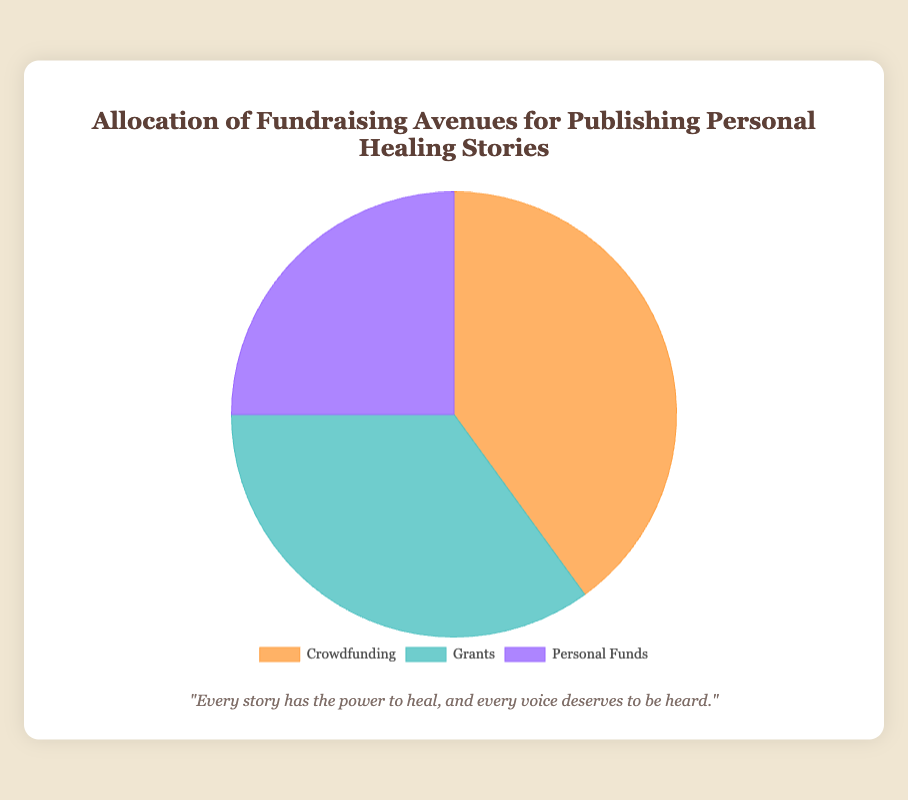What percentage of funds come from crowdfunding sources combined? According to the chart, crowdfunding accounts for 40% of the total fundraising avenues.
Answer: 40% Which fundraising avenue has the smallest percentage allocation? By looking at the pie chart, it's clear that Personal Funds have the smallest percentage at 25%.
Answer: Personal Funds Which avenue contributes more, Crowdfunding or Grants, and by how much? Crowdfunding accounts for 40% and Grants account for 35%. The difference between these two is 40% - 35%.
Answer: Crowdfunding by 5% What is the average percentage allocation across all three fundraising methods? To find the average, sum the percentages of all three methods: 40% (Crowdfunding) + 35% (Grants) + 25% (Personal Funds) = 100%, then divide by 3.
Answer: 33.33% Which section of the pie chart is represented by a bluish color? The bluish color in the pie chart represents Grants.
Answer: Grants How much more percentage comes from crowdfunding compared to personal funds? Crowdfunding is 40% and Personal Funds are 25%. The difference is 40% - 25%.
Answer: 15% What is the total percentage shared by Crowdfunding and Personal Funds? Sum the percentages of Crowdfunding (40%) and Personal Funds (25%): 40% + 25%.
Answer: 65% Which fundraising avenue appears to be the most significant contributor visually? Crowdfunding appears to be the most significant contributor at 40%, taking up the largest portion of the pie chart.
Answer: Crowdfunding 